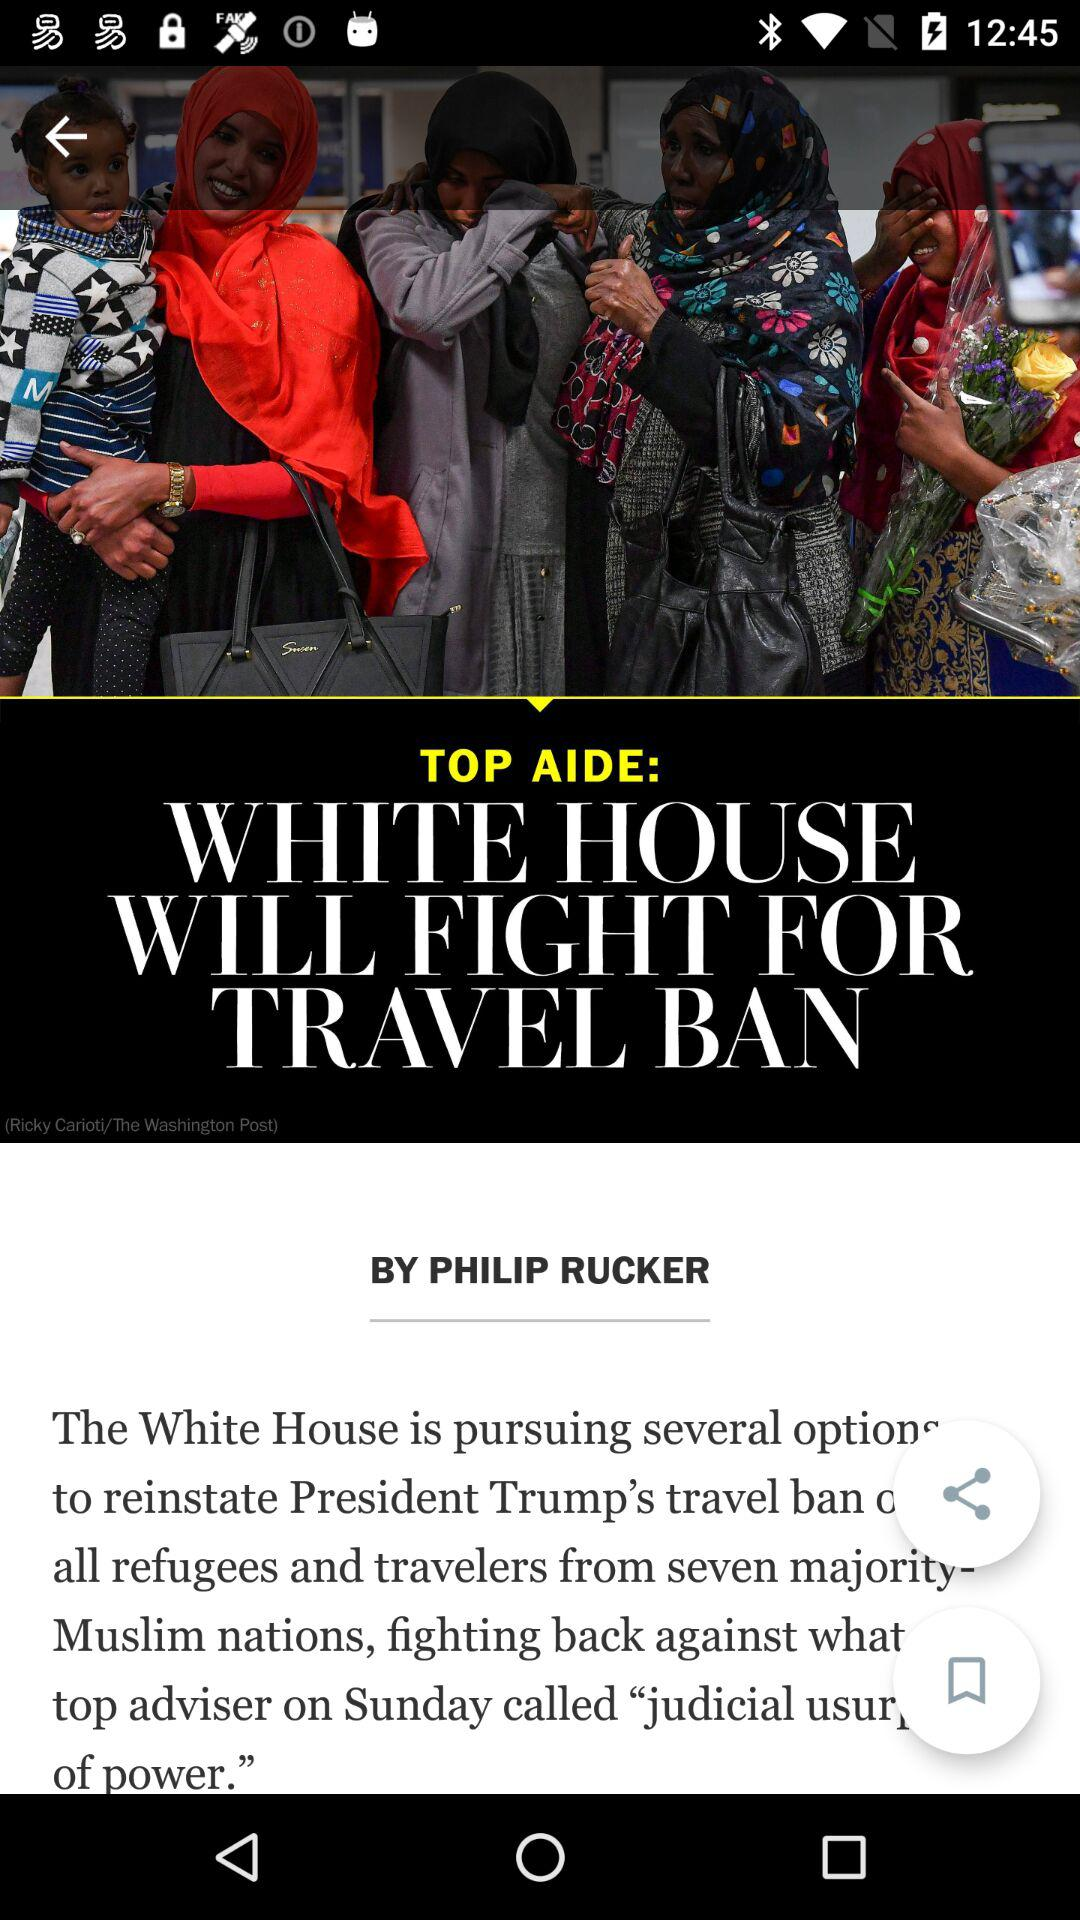Who is the author of the article? The author of the article is Philip Rucker. 